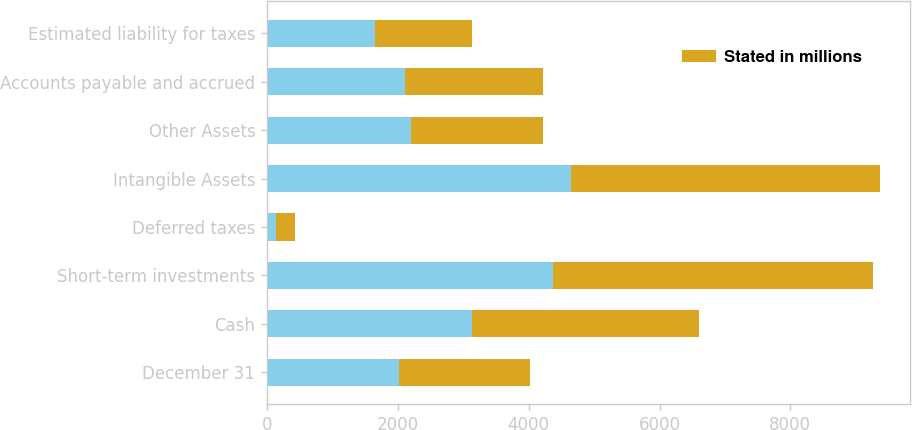Convert chart to OTSL. <chart><loc_0><loc_0><loc_500><loc_500><stacked_bar_chart><ecel><fcel>December 31<fcel>Cash<fcel>Short-term investments<fcel>Deferred taxes<fcel>Intangible Assets<fcel>Other Assets<fcel>Accounts payable and accrued<fcel>Estimated liability for taxes<nl><fcel>nan<fcel>2014<fcel>3130<fcel>4371<fcel>144<fcel>4654<fcel>2203<fcel>2110<fcel>1647<nl><fcel>Stated in millions<fcel>2013<fcel>3472<fcel>4898<fcel>288<fcel>4709<fcel>2017<fcel>2110<fcel>1490<nl></chart> 